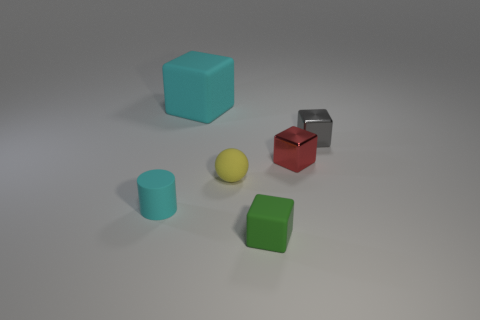Subtract 2 blocks. How many blocks are left? 2 Add 3 tiny yellow spheres. How many objects exist? 9 Subtract all cylinders. How many objects are left? 5 Subtract 1 cyan cubes. How many objects are left? 5 Subtract all red shiny spheres. Subtract all red things. How many objects are left? 5 Add 1 red metal things. How many red metal things are left? 2 Add 6 cyan rubber cylinders. How many cyan rubber cylinders exist? 7 